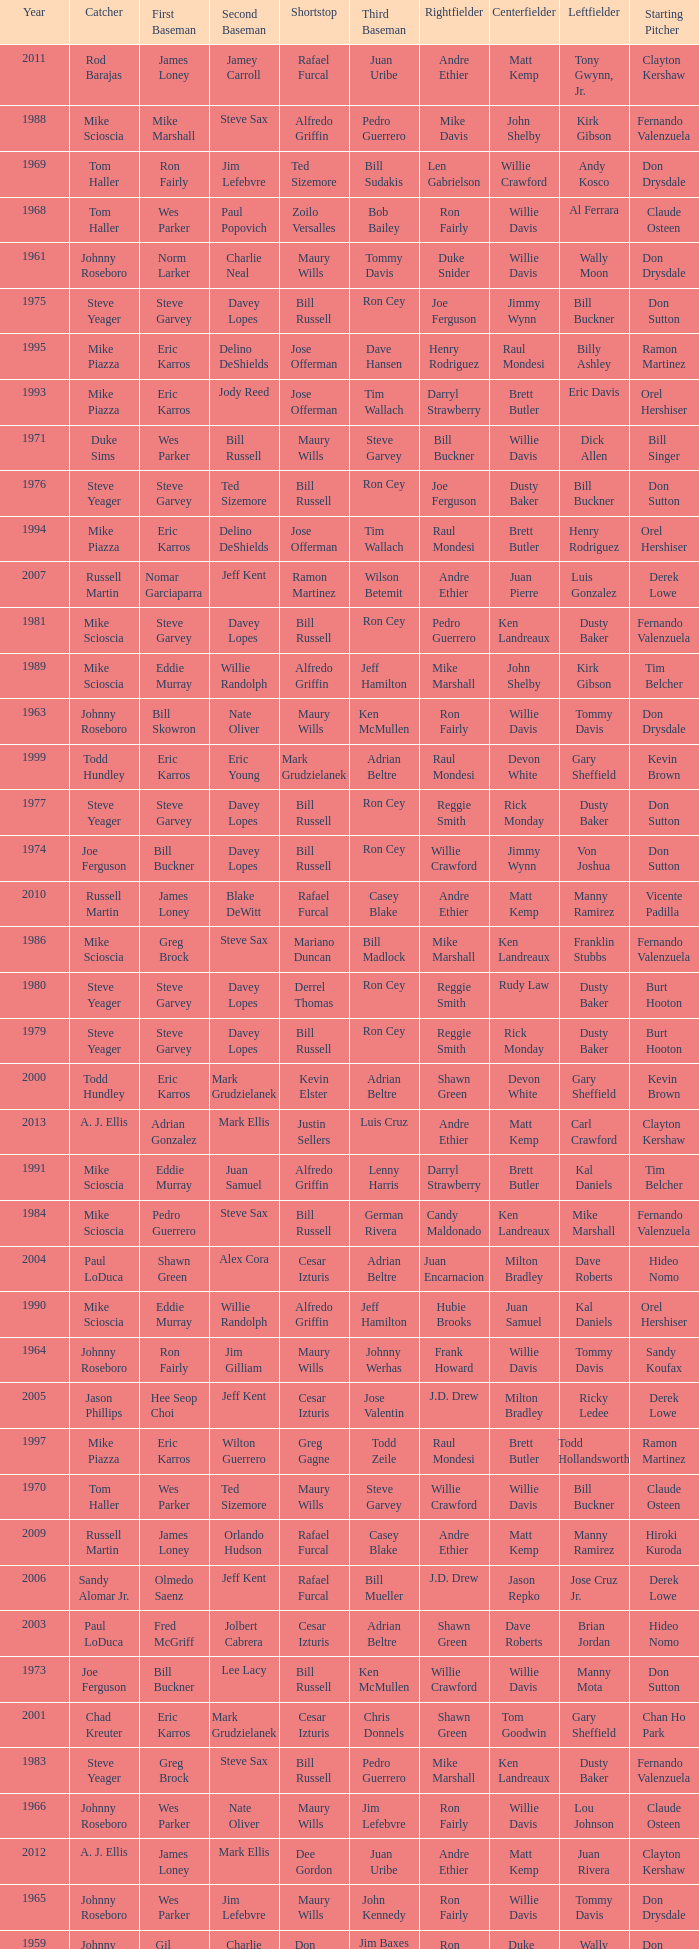I'm looking to parse the entire table for insights. Could you assist me with that? {'header': ['Year', 'Catcher', 'First Baseman', 'Second Baseman', 'Shortstop', 'Third Baseman', 'Rightfielder', 'Centerfielder', 'Leftfielder', 'Starting Pitcher'], 'rows': [['2011', 'Rod Barajas', 'James Loney', 'Jamey Carroll', 'Rafael Furcal', 'Juan Uribe', 'Andre Ethier', 'Matt Kemp', 'Tony Gwynn, Jr.', 'Clayton Kershaw'], ['1988', 'Mike Scioscia', 'Mike Marshall', 'Steve Sax', 'Alfredo Griffin', 'Pedro Guerrero', 'Mike Davis', 'John Shelby', 'Kirk Gibson', 'Fernando Valenzuela'], ['1969', 'Tom Haller', 'Ron Fairly', 'Jim Lefebvre', 'Ted Sizemore', 'Bill Sudakis', 'Len Gabrielson', 'Willie Crawford', 'Andy Kosco', 'Don Drysdale'], ['1968', 'Tom Haller', 'Wes Parker', 'Paul Popovich', 'Zoilo Versalles', 'Bob Bailey', 'Ron Fairly', 'Willie Davis', 'Al Ferrara', 'Claude Osteen'], ['1961', 'Johnny Roseboro', 'Norm Larker', 'Charlie Neal', 'Maury Wills', 'Tommy Davis', 'Duke Snider', 'Willie Davis', 'Wally Moon', 'Don Drysdale'], ['1975', 'Steve Yeager', 'Steve Garvey', 'Davey Lopes', 'Bill Russell', 'Ron Cey', 'Joe Ferguson', 'Jimmy Wynn', 'Bill Buckner', 'Don Sutton'], ['1995', 'Mike Piazza', 'Eric Karros', 'Delino DeShields', 'Jose Offerman', 'Dave Hansen', 'Henry Rodriguez', 'Raul Mondesi', 'Billy Ashley', 'Ramon Martinez'], ['1993', 'Mike Piazza', 'Eric Karros', 'Jody Reed', 'Jose Offerman', 'Tim Wallach', 'Darryl Strawberry', 'Brett Butler', 'Eric Davis', 'Orel Hershiser'], ['1971', 'Duke Sims', 'Wes Parker', 'Bill Russell', 'Maury Wills', 'Steve Garvey', 'Bill Buckner', 'Willie Davis', 'Dick Allen', 'Bill Singer'], ['1976', 'Steve Yeager', 'Steve Garvey', 'Ted Sizemore', 'Bill Russell', 'Ron Cey', 'Joe Ferguson', 'Dusty Baker', 'Bill Buckner', 'Don Sutton'], ['1994', 'Mike Piazza', 'Eric Karros', 'Delino DeShields', 'Jose Offerman', 'Tim Wallach', 'Raul Mondesi', 'Brett Butler', 'Henry Rodriguez', 'Orel Hershiser'], ['2007', 'Russell Martin', 'Nomar Garciaparra', 'Jeff Kent', 'Ramon Martinez', 'Wilson Betemit', 'Andre Ethier', 'Juan Pierre', 'Luis Gonzalez', 'Derek Lowe'], ['1981', 'Mike Scioscia', 'Steve Garvey', 'Davey Lopes', 'Bill Russell', 'Ron Cey', 'Pedro Guerrero', 'Ken Landreaux', 'Dusty Baker', 'Fernando Valenzuela'], ['1989', 'Mike Scioscia', 'Eddie Murray', 'Willie Randolph', 'Alfredo Griffin', 'Jeff Hamilton', 'Mike Marshall', 'John Shelby', 'Kirk Gibson', 'Tim Belcher'], ['1963', 'Johnny Roseboro', 'Bill Skowron', 'Nate Oliver', 'Maury Wills', 'Ken McMullen', 'Ron Fairly', 'Willie Davis', 'Tommy Davis', 'Don Drysdale'], ['1999', 'Todd Hundley', 'Eric Karros', 'Eric Young', 'Mark Grudzielanek', 'Adrian Beltre', 'Raul Mondesi', 'Devon White', 'Gary Sheffield', 'Kevin Brown'], ['1977', 'Steve Yeager', 'Steve Garvey', 'Davey Lopes', 'Bill Russell', 'Ron Cey', 'Reggie Smith', 'Rick Monday', 'Dusty Baker', 'Don Sutton'], ['1974', 'Joe Ferguson', 'Bill Buckner', 'Davey Lopes', 'Bill Russell', 'Ron Cey', 'Willie Crawford', 'Jimmy Wynn', 'Von Joshua', 'Don Sutton'], ['2010', 'Russell Martin', 'James Loney', 'Blake DeWitt', 'Rafael Furcal', 'Casey Blake', 'Andre Ethier', 'Matt Kemp', 'Manny Ramirez', 'Vicente Padilla'], ['1986', 'Mike Scioscia', 'Greg Brock', 'Steve Sax', 'Mariano Duncan', 'Bill Madlock', 'Mike Marshall', 'Ken Landreaux', 'Franklin Stubbs', 'Fernando Valenzuela'], ['1980', 'Steve Yeager', 'Steve Garvey', 'Davey Lopes', 'Derrel Thomas', 'Ron Cey', 'Reggie Smith', 'Rudy Law', 'Dusty Baker', 'Burt Hooton'], ['1979', 'Steve Yeager', 'Steve Garvey', 'Davey Lopes', 'Bill Russell', 'Ron Cey', 'Reggie Smith', 'Rick Monday', 'Dusty Baker', 'Burt Hooton'], ['2000', 'Todd Hundley', 'Eric Karros', 'Mark Grudzielanek', 'Kevin Elster', 'Adrian Beltre', 'Shawn Green', 'Devon White', 'Gary Sheffield', 'Kevin Brown'], ['2013', 'A. J. Ellis', 'Adrian Gonzalez', 'Mark Ellis', 'Justin Sellers', 'Luis Cruz', 'Andre Ethier', 'Matt Kemp', 'Carl Crawford', 'Clayton Kershaw'], ['1991', 'Mike Scioscia', 'Eddie Murray', 'Juan Samuel', 'Alfredo Griffin', 'Lenny Harris', 'Darryl Strawberry', 'Brett Butler', 'Kal Daniels', 'Tim Belcher'], ['1984', 'Mike Scioscia', 'Pedro Guerrero', 'Steve Sax', 'Bill Russell', 'German Rivera', 'Candy Maldonado', 'Ken Landreaux', 'Mike Marshall', 'Fernando Valenzuela'], ['2004', 'Paul LoDuca', 'Shawn Green', 'Alex Cora', 'Cesar Izturis', 'Adrian Beltre', 'Juan Encarnacion', 'Milton Bradley', 'Dave Roberts', 'Hideo Nomo'], ['1990', 'Mike Scioscia', 'Eddie Murray', 'Willie Randolph', 'Alfredo Griffin', 'Jeff Hamilton', 'Hubie Brooks', 'Juan Samuel', 'Kal Daniels', 'Orel Hershiser'], ['1964', 'Johnny Roseboro', 'Ron Fairly', 'Jim Gilliam', 'Maury Wills', 'Johnny Werhas', 'Frank Howard', 'Willie Davis', 'Tommy Davis', 'Sandy Koufax'], ['2005', 'Jason Phillips', 'Hee Seop Choi', 'Jeff Kent', 'Cesar Izturis', 'Jose Valentin', 'J.D. Drew', 'Milton Bradley', 'Ricky Ledee', 'Derek Lowe'], ['1997', 'Mike Piazza', 'Eric Karros', 'Wilton Guerrero', 'Greg Gagne', 'Todd Zeile', 'Raul Mondesi', 'Brett Butler', 'Todd Hollandsworth', 'Ramon Martinez'], ['1970', 'Tom Haller', 'Wes Parker', 'Ted Sizemore', 'Maury Wills', 'Steve Garvey', 'Willie Crawford', 'Willie Davis', 'Bill Buckner', 'Claude Osteen'], ['2009', 'Russell Martin', 'James Loney', 'Orlando Hudson', 'Rafael Furcal', 'Casey Blake', 'Andre Ethier', 'Matt Kemp', 'Manny Ramirez', 'Hiroki Kuroda'], ['2006', 'Sandy Alomar Jr.', 'Olmedo Saenz', 'Jeff Kent', 'Rafael Furcal', 'Bill Mueller', 'J.D. Drew', 'Jason Repko', 'Jose Cruz Jr.', 'Derek Lowe'], ['2003', 'Paul LoDuca', 'Fred McGriff', 'Jolbert Cabrera', 'Cesar Izturis', 'Adrian Beltre', 'Shawn Green', 'Dave Roberts', 'Brian Jordan', 'Hideo Nomo'], ['1973', 'Joe Ferguson', 'Bill Buckner', 'Lee Lacy', 'Bill Russell', 'Ken McMullen', 'Willie Crawford', 'Willie Davis', 'Manny Mota', 'Don Sutton'], ['2001', 'Chad Kreuter', 'Eric Karros', 'Mark Grudzielanek', 'Cesar Izturis', 'Chris Donnels', 'Shawn Green', 'Tom Goodwin', 'Gary Sheffield', 'Chan Ho Park'], ['1983', 'Steve Yeager', 'Greg Brock', 'Steve Sax', 'Bill Russell', 'Pedro Guerrero', 'Mike Marshall', 'Ken Landreaux', 'Dusty Baker', 'Fernando Valenzuela'], ['1966', 'Johnny Roseboro', 'Wes Parker', 'Nate Oliver', 'Maury Wills', 'Jim Lefebvre', 'Ron Fairly', 'Willie Davis', 'Lou Johnson', 'Claude Osteen'], ['2012', 'A. J. Ellis', 'James Loney', 'Mark Ellis', 'Dee Gordon', 'Juan Uribe', 'Andre Ethier', 'Matt Kemp', 'Juan Rivera', 'Clayton Kershaw'], ['1965', 'Johnny Roseboro', 'Wes Parker', 'Jim Lefebvre', 'Maury Wills', 'John Kennedy', 'Ron Fairly', 'Willie Davis', 'Tommy Davis', 'Don Drysdale'], ['1959', 'Johnny Roseboro', 'Gil Hodges', 'Charlie Neal', 'Don Zimmer', 'Jim Baxes', 'Ron Fairly', 'Duke Snider', 'Wally Moon', 'Don Drysdale'], ['1996', 'Mike Piazza', 'Eric Karros', 'Delino DeShields', 'Greg Gagne', 'Mike Blowers', 'Raul Mondesi', 'Brett Butler', 'Todd Hollandsworth', 'Ramon Martinez'], ['2008', 'Russell Martin', 'James Loney', 'Jeff Kent', 'Rafael Furcal', 'Blake DeWitt', 'Matt Kemp', 'Andruw Jones', 'Andre Ethier', 'Brad Penny'], ['1982', 'Steve Yeager', 'Steve Garvey', 'Steve Sax', 'Bill Russell', 'Ron Cey', 'Pedro Guerrero', 'Ken Landreaux', 'Dusty Baker', 'Jerry Reuss'], ['1972', 'Duke Sims', 'Bill Buckner', 'Jim Lefebvre', 'Maury Wills', 'Billy Grabarkewitz', 'Frank Robinson', 'Willie Davis', 'Willie Crawford', 'Don Sutton'], ['1992', 'Mike Scioscia', 'Kal Daniels', 'Juan Samuel', 'Jose Offerman', 'Lenny Harris', 'Darryl Strawberry', 'Brett Butler', 'Eric Davis', 'Ramon Martinez'], ['1962', 'Johnny Roseboro', 'Ron Fairly', 'Jim Gilliam', 'Maury Wills', 'Daryl Spencer', 'Duke Snider', 'Willie Davis', 'Wally Moon', 'Johnny Podres'], ['2002', 'Paul LoDuca', 'Eric Karros', 'Mark Grudzielanek', 'Cesar Izturis', 'Adrian Beltre', 'Shawn Green', 'Dave Roberts', 'Brian Jordan', 'Kevin Brown'], ['1978', 'Steve Yeager', 'Steve Garvey', 'Davey Lopes', 'Bill Russell', 'Ron Cey', 'Reggie Smith', 'Rick Monday', 'Dusty Baker', 'Don Sutton'], ['1985', 'Mike Scioscia', 'Sid Bream', 'Mariano Duncan', 'Dave Anderson', 'Pedro Guerrero', 'Mike Marshall', 'Ken Landreaux', 'Al Oliver', 'Fernando Valenzuela'], ['1987', 'Mike Scioscia', 'Franklin Stubbs', 'Steve Sax', 'Mariano Duncan', 'Bill Madlock', 'Mike Marshall', 'Mike Ramsey', 'Ken Landreaux', 'Orel Hershiser'], ['1960', 'Johnny Roseboro', 'Gil Hodges', 'Charlie Neal', 'Maury Wills', 'Jim Gilliam', 'Duke Snider', 'Don Demeter', 'Wally Moon', 'Don Drysdale'], ['1967', 'Johnny Roseboro', 'Ron Fairly', 'Ron Hunt', 'Gene Michael', 'Jim Lefebvre', 'Lou Johnson', 'Wes Parker', 'Bob Bailey', 'Bob Miller'], ['1998', 'Mike Piazza', 'Paul Konerko', 'Eric Young', 'Jose Vizcaino', 'Todd Zeile', 'Raul Mondesi', 'Trenidad Hubbard', 'Todd Hollandsworth', 'Ramon Martinez']]} Who was the RF when the SP was vicente padilla? Andre Ethier. 